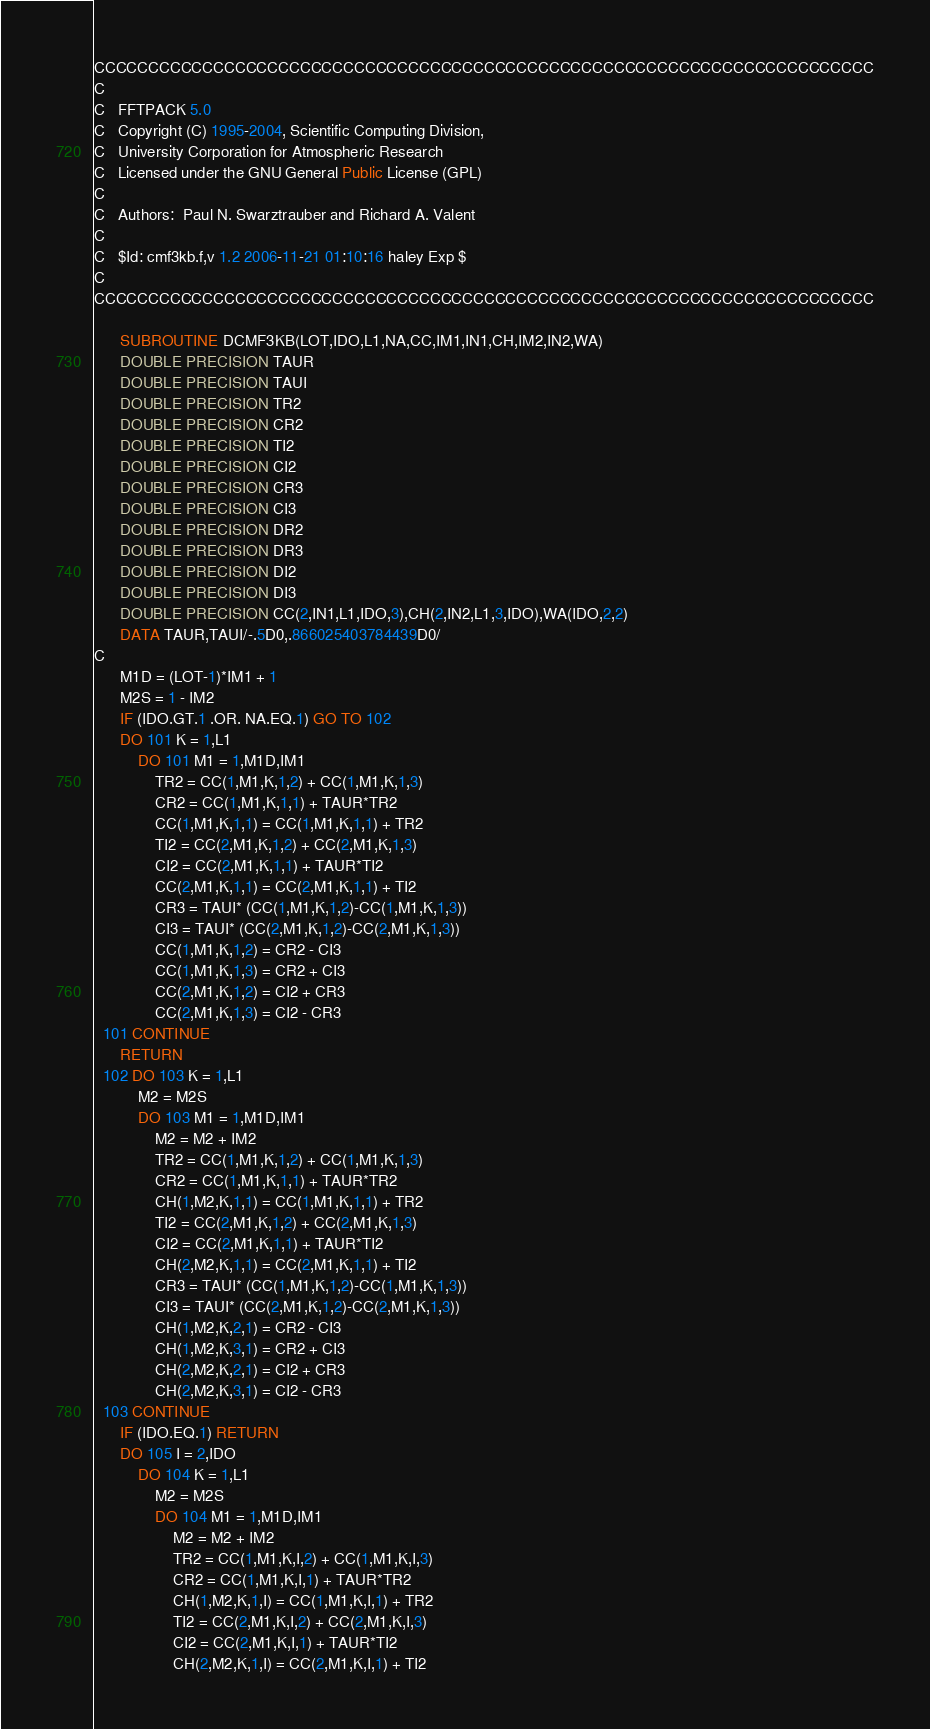Convert code to text. <code><loc_0><loc_0><loc_500><loc_500><_FORTRAN_>CCCCCCCCCCCCCCCCCCCCCCCCCCCCCCCCCCCCCCCCCCCCCCCCCCCCCCCCCCCCCCCCCCCCCCCC
C
C   FFTPACK 5.0
C   Copyright (C) 1995-2004, Scientific Computing Division,
C   University Corporation for Atmospheric Research
C   Licensed under the GNU General Public License (GPL)
C
C   Authors:  Paul N. Swarztrauber and Richard A. Valent
C
C   $Id: cmf3kb.f,v 1.2 2006-11-21 01:10:16 haley Exp $
C
CCCCCCCCCCCCCCCCCCCCCCCCCCCCCCCCCCCCCCCCCCCCCCCCCCCCCCCCCCCCCCCCCCCCCCCC

      SUBROUTINE DCMF3KB(LOT,IDO,L1,NA,CC,IM1,IN1,CH,IM2,IN2,WA)
      DOUBLE PRECISION TAUR
      DOUBLE PRECISION TAUI
      DOUBLE PRECISION TR2
      DOUBLE PRECISION CR2
      DOUBLE PRECISION TI2
      DOUBLE PRECISION CI2
      DOUBLE PRECISION CR3
      DOUBLE PRECISION CI3
      DOUBLE PRECISION DR2
      DOUBLE PRECISION DR3
      DOUBLE PRECISION DI2
      DOUBLE PRECISION DI3
      DOUBLE PRECISION CC(2,IN1,L1,IDO,3),CH(2,IN2,L1,3,IDO),WA(IDO,2,2)
      DATA TAUR,TAUI/-.5D0,.866025403784439D0/
C
      M1D = (LOT-1)*IM1 + 1
      M2S = 1 - IM2
      IF (IDO.GT.1 .OR. NA.EQ.1) GO TO 102
      DO 101 K = 1,L1
          DO 101 M1 = 1,M1D,IM1
              TR2 = CC(1,M1,K,1,2) + CC(1,M1,K,1,3)
              CR2 = CC(1,M1,K,1,1) + TAUR*TR2
              CC(1,M1,K,1,1) = CC(1,M1,K,1,1) + TR2
              TI2 = CC(2,M1,K,1,2) + CC(2,M1,K,1,3)
              CI2 = CC(2,M1,K,1,1) + TAUR*TI2
              CC(2,M1,K,1,1) = CC(2,M1,K,1,1) + TI2
              CR3 = TAUI* (CC(1,M1,K,1,2)-CC(1,M1,K,1,3))
              CI3 = TAUI* (CC(2,M1,K,1,2)-CC(2,M1,K,1,3))
              CC(1,M1,K,1,2) = CR2 - CI3
              CC(1,M1,K,1,3) = CR2 + CI3
              CC(2,M1,K,1,2) = CI2 + CR3
              CC(2,M1,K,1,3) = CI2 - CR3
  101 CONTINUE
      RETURN
  102 DO 103 K = 1,L1
          M2 = M2S
          DO 103 M1 = 1,M1D,IM1
              M2 = M2 + IM2
              TR2 = CC(1,M1,K,1,2) + CC(1,M1,K,1,3)
              CR2 = CC(1,M1,K,1,1) + TAUR*TR2
              CH(1,M2,K,1,1) = CC(1,M1,K,1,1) + TR2
              TI2 = CC(2,M1,K,1,2) + CC(2,M1,K,1,3)
              CI2 = CC(2,M1,K,1,1) + TAUR*TI2
              CH(2,M2,K,1,1) = CC(2,M1,K,1,1) + TI2
              CR3 = TAUI* (CC(1,M1,K,1,2)-CC(1,M1,K,1,3))
              CI3 = TAUI* (CC(2,M1,K,1,2)-CC(2,M1,K,1,3))
              CH(1,M2,K,2,1) = CR2 - CI3
              CH(1,M2,K,3,1) = CR2 + CI3
              CH(2,M2,K,2,1) = CI2 + CR3
              CH(2,M2,K,3,1) = CI2 - CR3
  103 CONTINUE
      IF (IDO.EQ.1) RETURN
      DO 105 I = 2,IDO
          DO 104 K = 1,L1
              M2 = M2S
              DO 104 M1 = 1,M1D,IM1
                  M2 = M2 + IM2
                  TR2 = CC(1,M1,K,I,2) + CC(1,M1,K,I,3)
                  CR2 = CC(1,M1,K,I,1) + TAUR*TR2
                  CH(1,M2,K,1,I) = CC(1,M1,K,I,1) + TR2
                  TI2 = CC(2,M1,K,I,2) + CC(2,M1,K,I,3)
                  CI2 = CC(2,M1,K,I,1) + TAUR*TI2
                  CH(2,M2,K,1,I) = CC(2,M1,K,I,1) + TI2</code> 